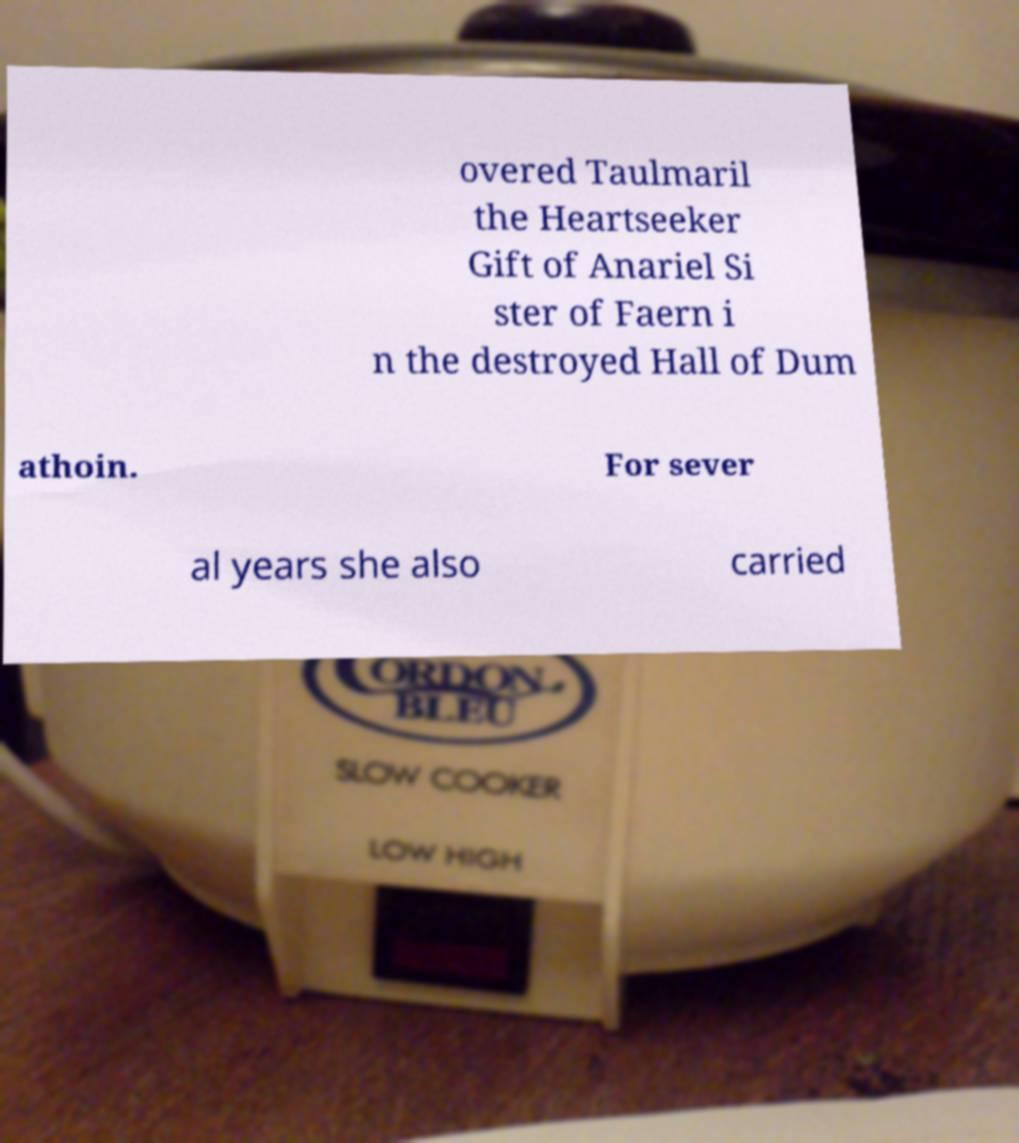Can you read and provide the text displayed in the image?This photo seems to have some interesting text. Can you extract and type it out for me? overed Taulmaril the Heartseeker Gift of Anariel Si ster of Faern i n the destroyed Hall of Dum athoin. For sever al years she also carried 